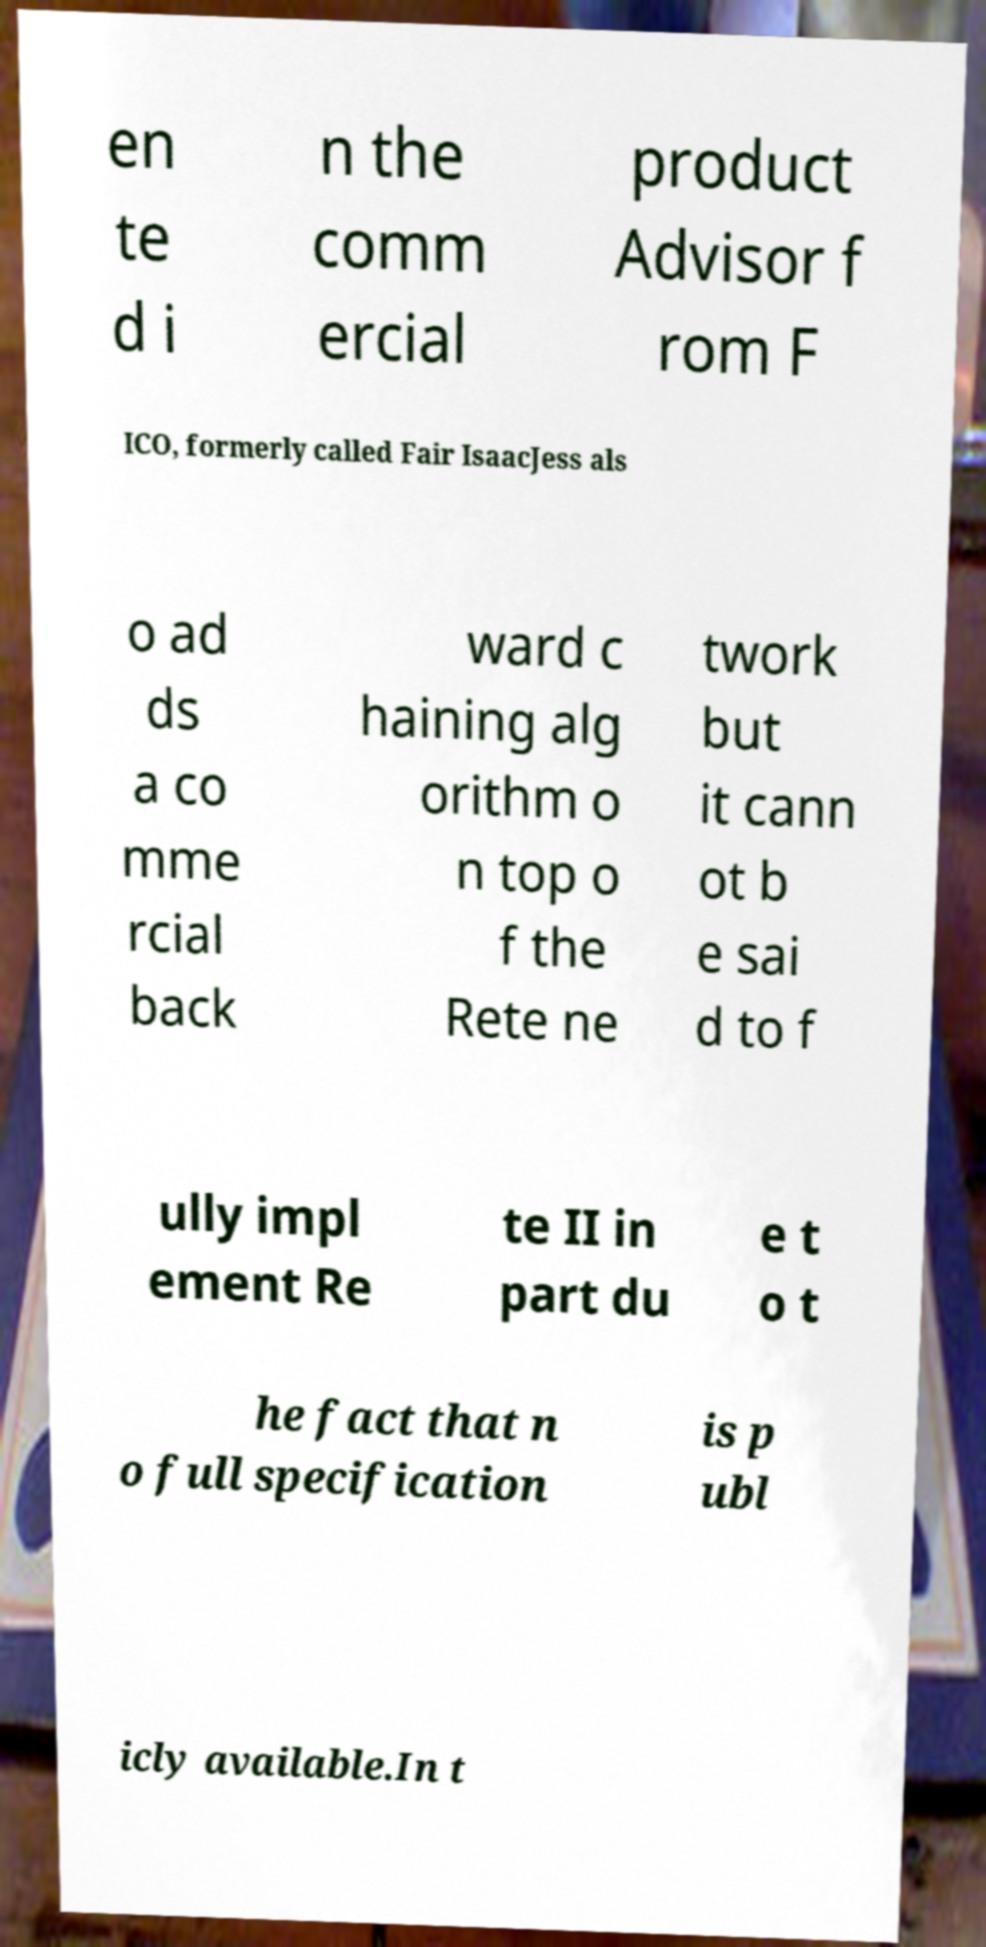There's text embedded in this image that I need extracted. Can you transcribe it verbatim? en te d i n the comm ercial product Advisor f rom F ICO, formerly called Fair IsaacJess als o ad ds a co mme rcial back ward c haining alg orithm o n top o f the Rete ne twork but it cann ot b e sai d to f ully impl ement Re te II in part du e t o t he fact that n o full specification is p ubl icly available.In t 